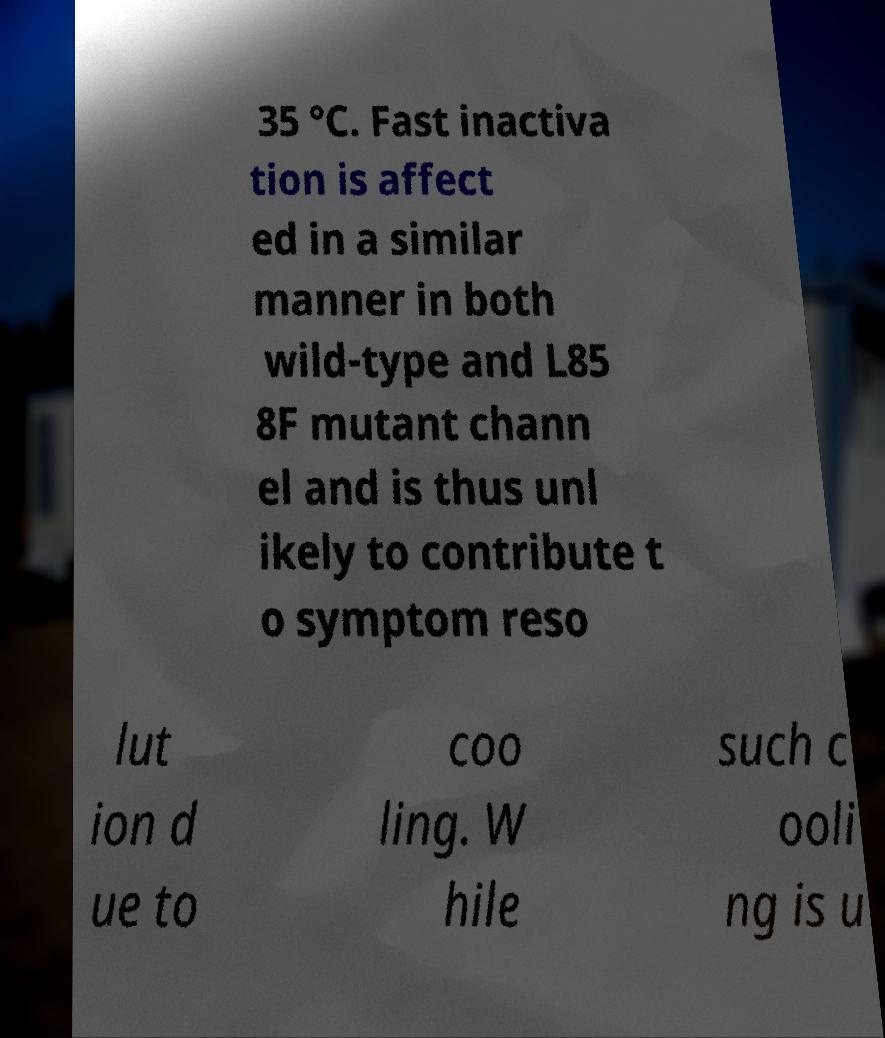Could you assist in decoding the text presented in this image and type it out clearly? 35 °C. Fast inactiva tion is affect ed in a similar manner in both wild-type and L85 8F mutant chann el and is thus unl ikely to contribute t o symptom reso lut ion d ue to coo ling. W hile such c ooli ng is u 